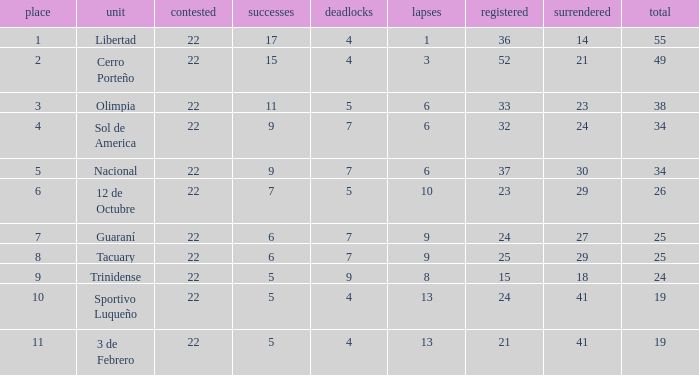Give me the full table as a dictionary. {'header': ['place', 'unit', 'contested', 'successes', 'deadlocks', 'lapses', 'registered', 'surrendered', 'total'], 'rows': [['1', 'Libertad', '22', '17', '4', '1', '36', '14', '55'], ['2', 'Cerro Porteño', '22', '15', '4', '3', '52', '21', '49'], ['3', 'Olimpia', '22', '11', '5', '6', '33', '23', '38'], ['4', 'Sol de America', '22', '9', '7', '6', '32', '24', '34'], ['5', 'Nacional', '22', '9', '7', '6', '37', '30', '34'], ['6', '12 de Octubre', '22', '7', '5', '10', '23', '29', '26'], ['7', 'Guaraní', '22', '6', '7', '9', '24', '27', '25'], ['8', 'Tacuary', '22', '6', '7', '9', '25', '29', '25'], ['9', 'Trinidense', '22', '5', '9', '8', '15', '18', '24'], ['10', 'Sportivo Luqueño', '22', '5', '4', '13', '24', '41', '19'], ['11', '3 de Febrero', '22', '5', '4', '13', '21', '41', '19']]} What is the value scored when there were 19 points for the team 3 de Febrero? 21.0. 